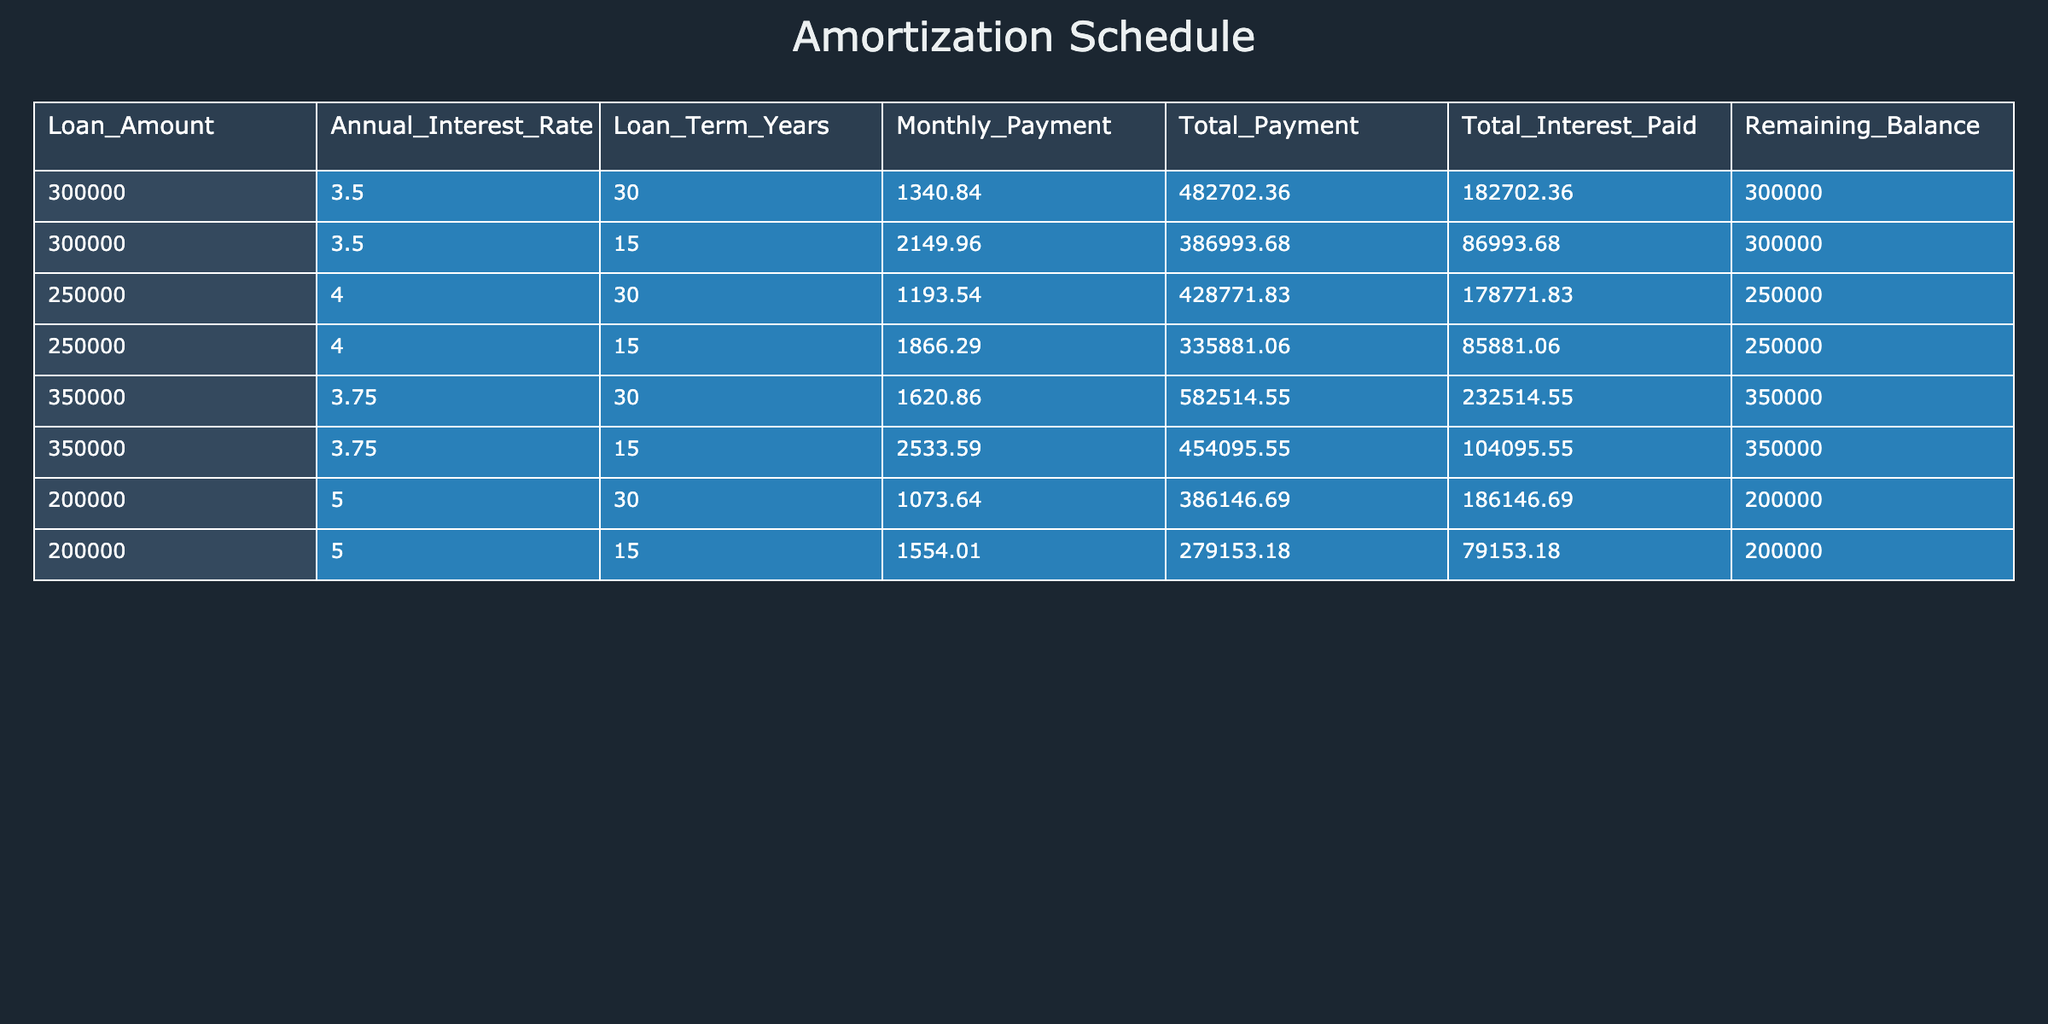what is the monthly payment for a 30-year mortgage with a loan amount of 300,000? The table shows that for a loan amount of 300,000 with a 30-year term, the monthly payment is listed directly. Therefore, the monthly payment is 1340.84.
Answer: 1340.84 how much total interest is paid on a 15-year mortgage with a loan amount of 250,000? The table indicates that the total interest paid for the 15-year mortgage at a loan amount of 250,000 is directly available, which is 85881.06.
Answer: 85881.06 what is the difference in total payment between a 30-year mortgage and a 15-year mortgage for a loan amount of 200,000? For the 30-year mortgage on 200,000, the total payment is 386146.69, and for the 15-year mortgage, it's 279153.18. The difference is calculated as 386146.69 - 279153.18 = 106993.51.
Answer: 106993.51 is the total interest paid higher for a 30-year mortgage than for a 15-year mortgage with the same loan amount of 350,000? The total interest paid for the 30-year mortgage on 350,000 is 232514.55, whereas for the 15-year mortgage, it's 104095.55. Since 232514.55 is greater than 104095.55, the answer is yes.
Answer: Yes what is the average monthly payment for all the 30-year mortgages listed in the table? The monthly payments for the 30-year mortgages are 1340.84, 1193.54, 1620.86, and 1073.64. Calculating the average involves adding these values (1340.84 + 1193.54 + 1620.86 + 1073.64 = 4228.88) and dividing by the number of entries (4228.88 / 4 = 1057.22).
Answer: 1057.22 which loan term has a higher average remaining balance: 30 years or 15 years? The remaining balances for the 30-year mortgages are 300000, 250000, 350000, and 200000, summing up to 1150000 and averaging 1150000 / 4 = 287500. For the 15-year mortgages, the remaining balances are also 300000, 250000, 350000, and 200000, summing to the same; hence the average is also 287500. Both averages are equal, so neither has a higher average remaining balance.
Answer: Neither how much total payment is made for a 15-year mortgage with an interest rate of 5.0%? In the table, the total payment for the 15-year mortgage at an interest rate of 5.0% is 279153.18, extracted directly from the data presented.
Answer: 279153.18 which loan amount has the highest total interest paid across all terms in this table? By examining the total interest paid for all loan amounts, we see the maximum is for the 350,000 mortgage (232514.55 for a 30-year term). Thereby, the answer is 350000 with total interest 232514.55.
Answer: 350000 if someone takes a 15-year mortgage of 200,000, how much do they pay in total interest? The table specifies that for a 15-year mortgage amount of 200,000, the total interest paid is listed directly as 79153.18.
Answer: 79153.18 